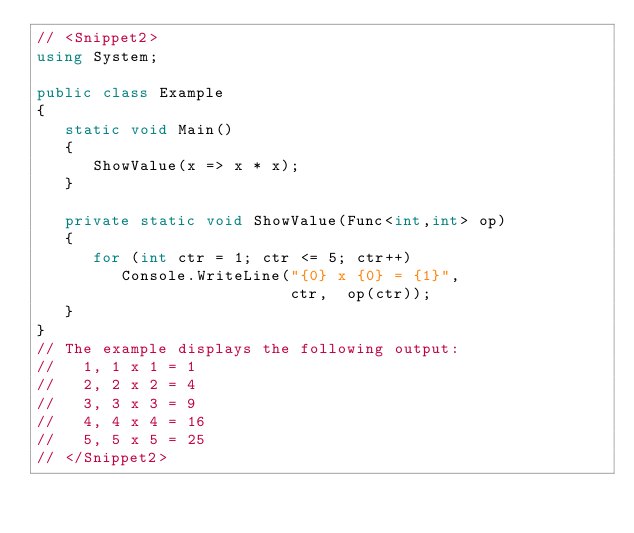<code> <loc_0><loc_0><loc_500><loc_500><_C#_>// <Snippet2>
using System;

public class Example
{
   static void Main()  
   {  
      ShowValue(x => x * x);  
   }  

   private static void ShowValue(Func<int,int> op)
   {
      for (int ctr = 1; ctr <= 5; ctr++)
         Console.WriteLine("{0} x {0} = {1}",
                           ctr,  op(ctr));
   }
}
// The example displays the following output:
//   1, 1 x 1 = 1
//   2, 2 x 2 = 4
//   3, 3 x 3 = 9
//   4, 4 x 4 = 16
//   5, 5 x 5 = 25
// </Snippet2>
</code> 